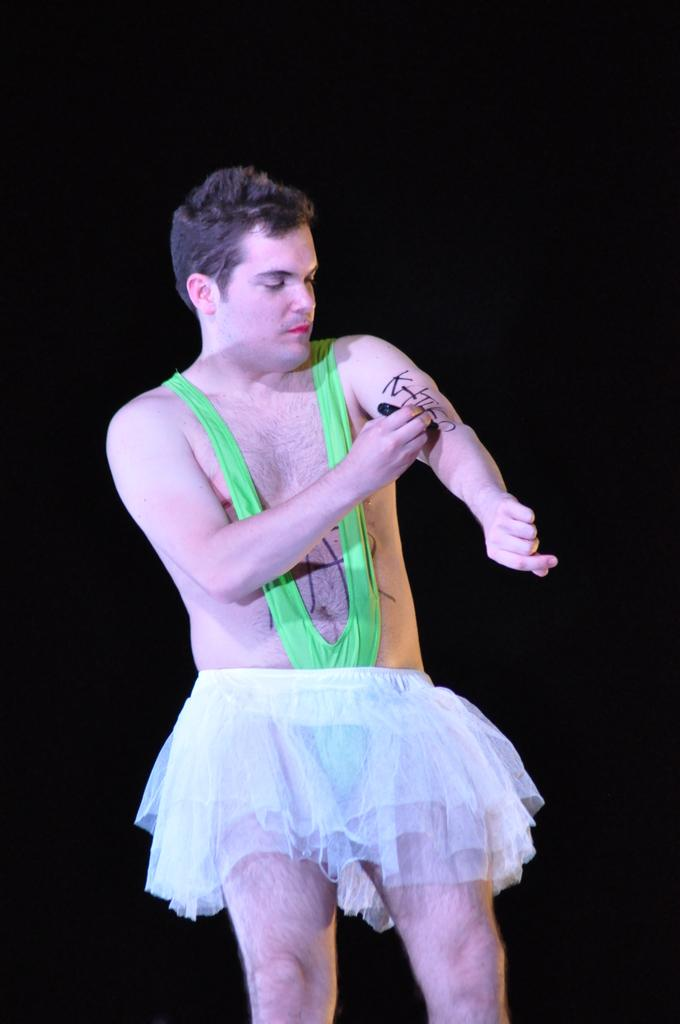What is the person in the image doing? The person is writing something on his hand. What tool is the person using to write on his hand? The person is using a marker to write on his hand. What type of attention is the person in the image seeking by writing on his hand? The image does not provide any information about the person seeking attention or the reason for writing on his hand. What role does the governor play in the image? There is no mention of a governor or any political figure in the image. 